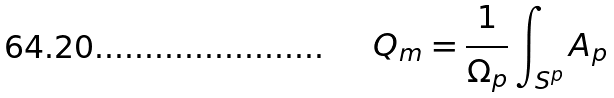<formula> <loc_0><loc_0><loc_500><loc_500>Q _ { m } = \frac { 1 } { \Omega _ { p } } \int _ { S ^ { p } } A _ { p }</formula> 